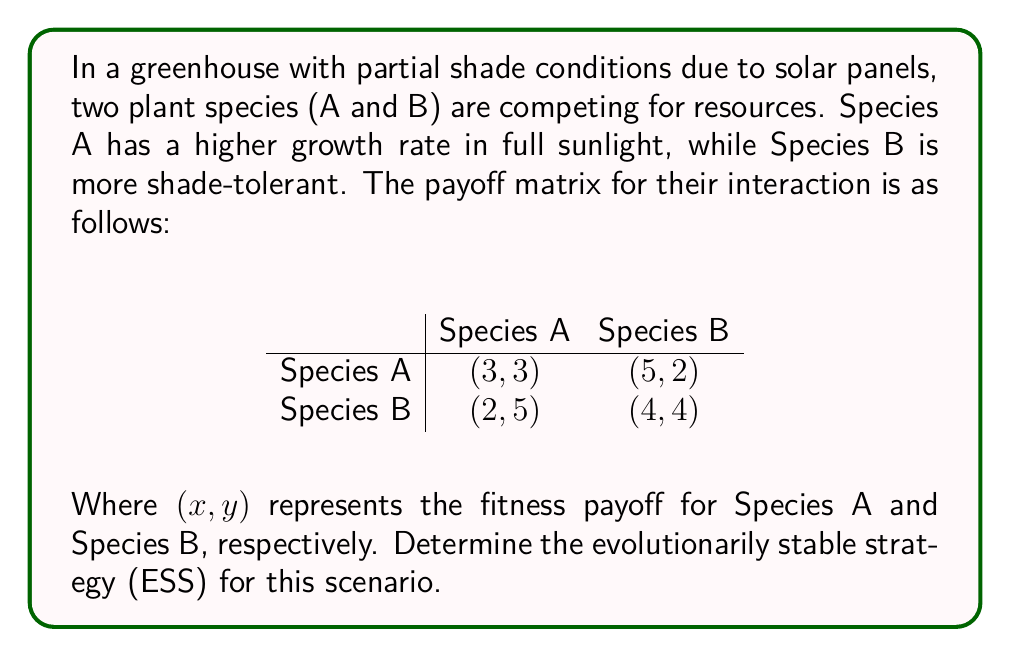Teach me how to tackle this problem. To determine the evolutionarily stable strategy (ESS), we need to analyze the payoff matrix and find a strategy that, when adopted by the entire population, cannot be invaded by any alternative strategy.

Step 1: Check for pure strategy ESS

1.1 For Species A to be a pure strategy ESS:
- $(3, 3)$ must be greater than $(2, 5)$
- This is not true, so Species A is not a pure strategy ESS

1.2 For Species B to be a pure strategy ESS:
- $(4, 4)$ must be greater than $(5, 2)$
- This is not true, so Species B is not a pure strategy ESS

Step 2: Check for mixed strategy ESS

Let $p$ be the probability of playing Species A strategy, and $(1-p)$ be the probability of playing Species B strategy.

2.1 Calculate the expected payoff for Species A:
$E(A) = 3p + 5(1-p) = 5 - 2p$

2.2 Calculate the expected payoff for Species B:
$E(B) = 2p + 4(1-p) = 4 - 2p$

2.3 For a mixed strategy ESS, these expected payoffs must be equal:
$E(A) = E(B)$
$5 - 2p = 4 - 2p$
$5 = 4$

This equation is always false, which means there is no mixed strategy ESS.

Step 3: Analyze the game dynamics

Since there is no pure or mixed strategy ESS, we need to analyze the game dynamics. In this case, we have a cyclic dominance:
- When Species A is prevalent, Species B has an advantage (5 > 3)
- When Species B is prevalent, Species A has an advantage (5 > 4)

This creates an oscillating population dynamic, where neither species can maintain a stable majority in the long term.
Answer: There is no evolutionarily stable strategy (ESS) for this scenario. Instead, the plant species will exhibit cyclic dominance, with populations of Species A and Species B oscillating over time as they adapt to the partial shade conditions in the greenhouse. 